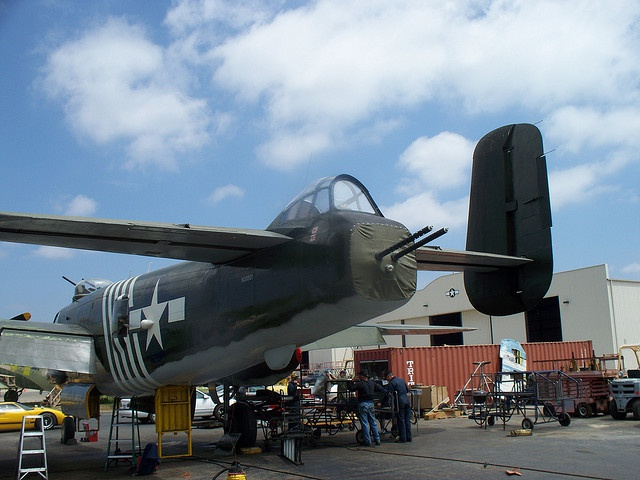Describe the objects in this image and their specific colors. I can see airplane in blue, black, gray, darkgray, and purple tones, truck in blue, brown, maroon, and black tones, car in blue, black, orange, olive, and white tones, truck in blue, black, and gray tones, and people in blue, black, navy, and gray tones in this image. 